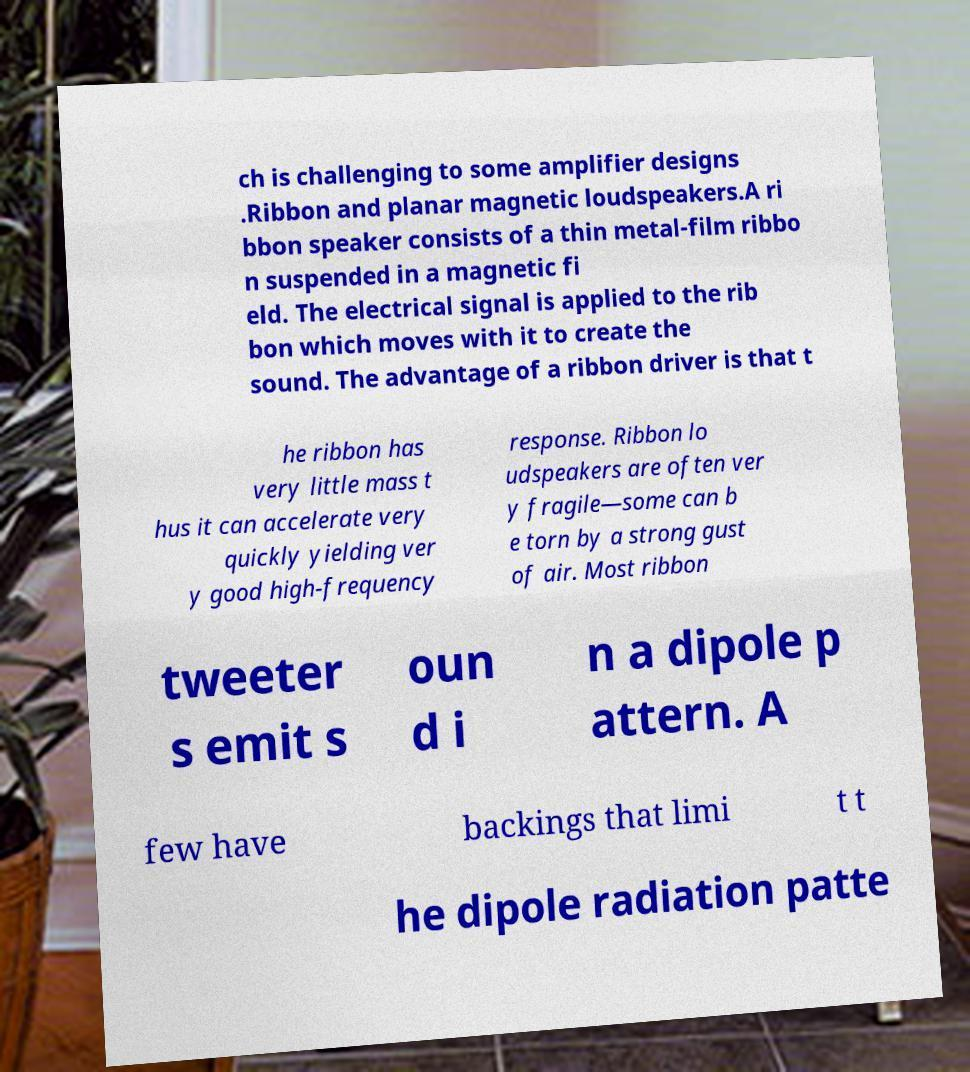Can you read and provide the text displayed in the image?This photo seems to have some interesting text. Can you extract and type it out for me? ch is challenging to some amplifier designs .Ribbon and planar magnetic loudspeakers.A ri bbon speaker consists of a thin metal-film ribbo n suspended in a magnetic fi eld. The electrical signal is applied to the rib bon which moves with it to create the sound. The advantage of a ribbon driver is that t he ribbon has very little mass t hus it can accelerate very quickly yielding ver y good high-frequency response. Ribbon lo udspeakers are often ver y fragile—some can b e torn by a strong gust of air. Most ribbon tweeter s emit s oun d i n a dipole p attern. A few have backings that limi t t he dipole radiation patte 